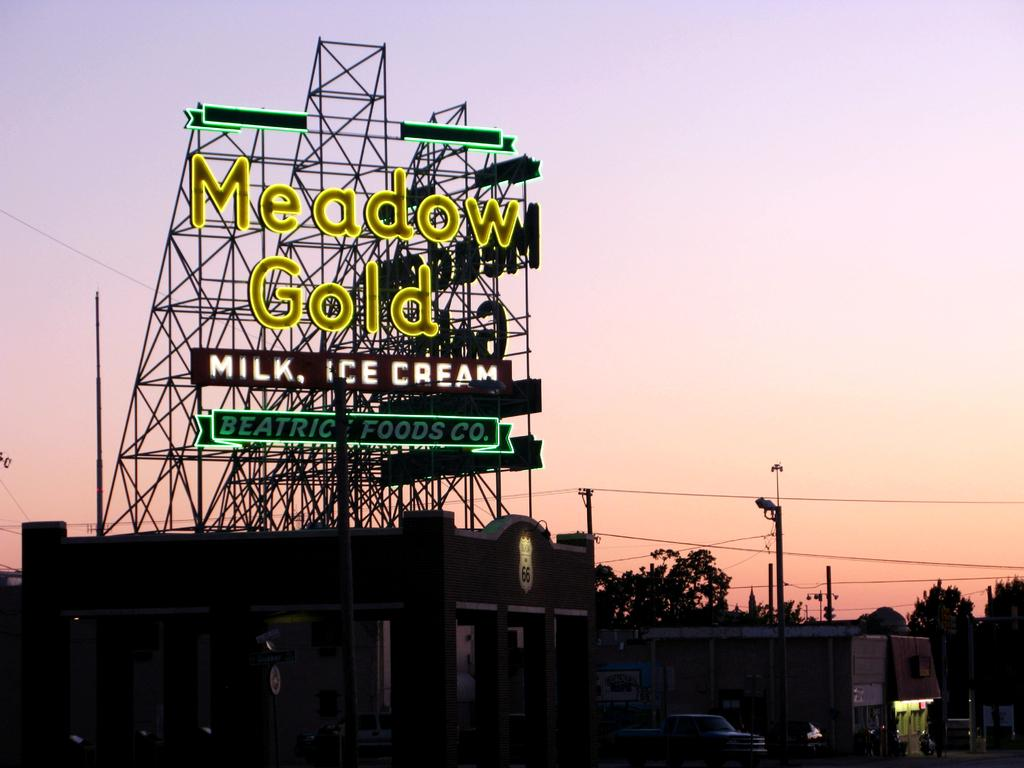What is the main object in the image? There is a hoarding in the image. What can be seen on the hoarding? The hoarding has letters on it. What type of structures are visible in the image? There are houses visible in the image. What else can be seen in the image besides the hoarding and houses? There are vehicles and trees in the image. Is there a horse participating in a protest in the image? There is no horse or protest present in the image. What word or phrase is used to stop people from doing something in the image? There is no specific word or phrase used to stop people from doing something in the image. 